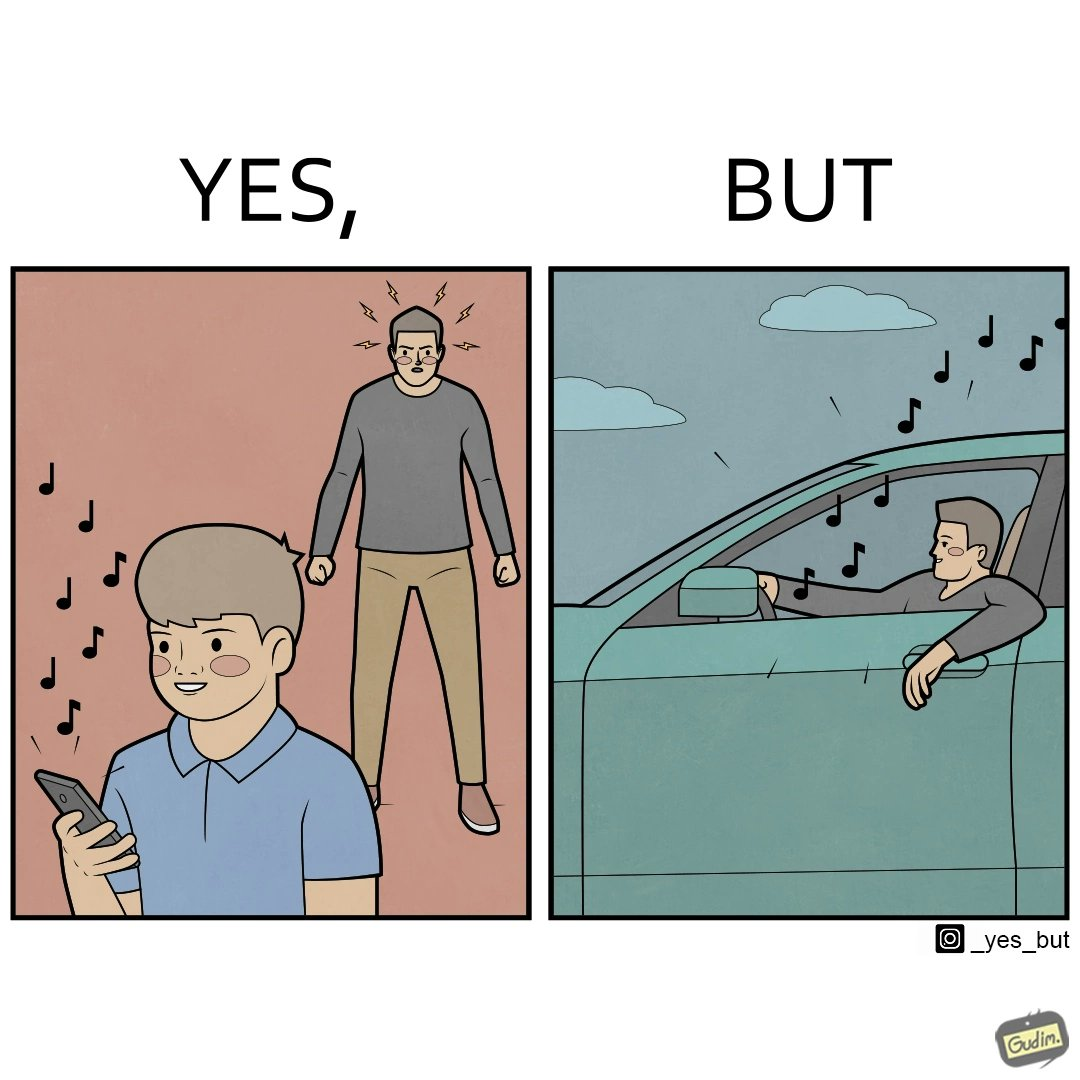Explain the humor or irony in this image. The image is funny because while the man does not like the boy playing music loudly on his phone, the man himself is okay with doing the same thing with his car and playing loud music in the car with the sound coming out of the car. 